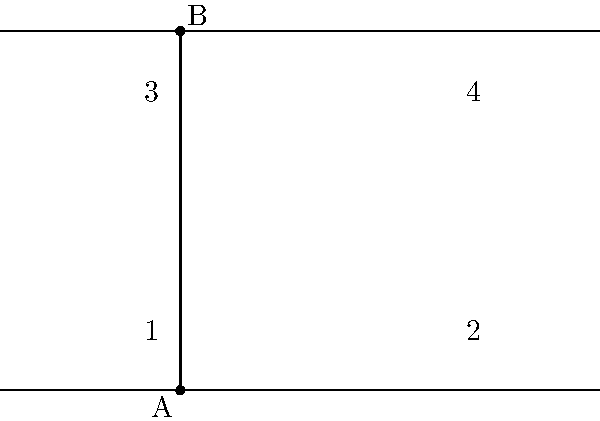In the peaceful garden of your retirement community, you notice two parallel flower beds intersected by a diagonal walkway. This reminds you of a geometry problem from your younger days. In the figure above, if lines AB and CD are parallel and intersected by transversal EF, what is the relationship between angles 1 and 3? Let's approach this step-by-step:

1) In the given figure, AB and CD are parallel lines, and EF is a transversal.

2) When a transversal intersects two parallel lines, it creates several pairs of special angles:
   - Corresponding angles
   - Alternate interior angles
   - Alternate exterior angles
   - Consecutive interior angles

3) Angles 1 and 3 are on the same side of the transversal but on different parallel lines. This configuration makes them alternate interior angles.

4) A fundamental theorem in geometry states that when two parallel lines are cut by a transversal, the alternate interior angles are congruent.

5) Therefore, angle 1 and angle 3 are congruent, which means they have the same measure.

This relationship holds true regardless of the specific measures of the angles or the distance between the parallel lines.
Answer: Congruent 